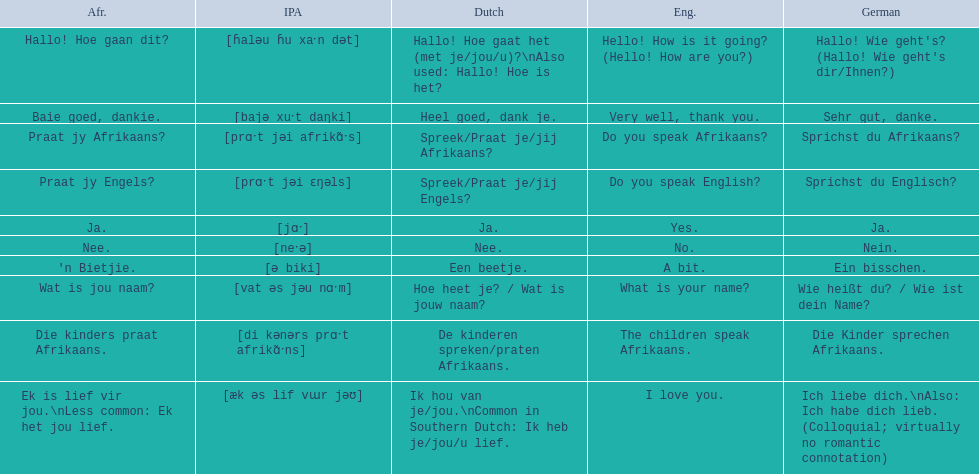Which phrases are said in africaans? Hallo! Hoe gaan dit?, Baie goed, dankie., Praat jy Afrikaans?, Praat jy Engels?, Ja., Nee., 'n Bietjie., Wat is jou naam?, Die kinders praat Afrikaans., Ek is lief vir jou.\nLess common: Ek het jou lief. Which of these mean how do you speak afrikaans? Praat jy Afrikaans?. 